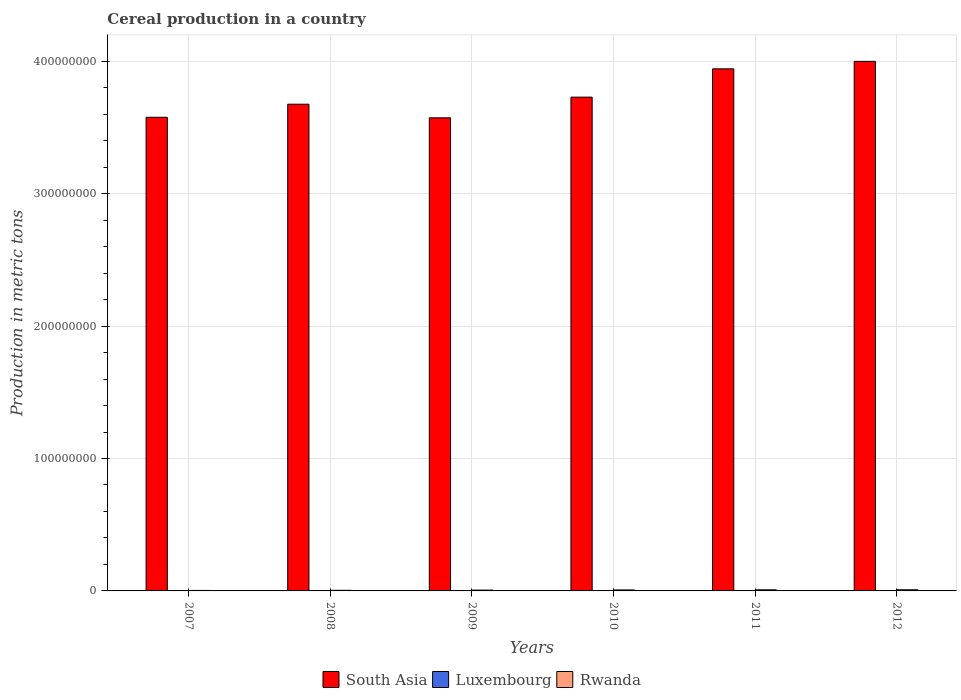How many groups of bars are there?
Provide a short and direct response. 6. How many bars are there on the 6th tick from the left?
Provide a succinct answer. 3. What is the label of the 5th group of bars from the left?
Provide a short and direct response. 2011. What is the total cereal production in Rwanda in 2009?
Offer a very short reply. 6.22e+05. Across all years, what is the maximum total cereal production in Rwanda?
Provide a succinct answer. 8.81e+05. Across all years, what is the minimum total cereal production in Luxembourg?
Offer a very short reply. 1.48e+05. In which year was the total cereal production in Luxembourg maximum?
Provide a succinct answer. 2008. In which year was the total cereal production in Luxembourg minimum?
Your response must be concise. 2007. What is the total total cereal production in Rwanda in the graph?
Your answer should be compact. 3.93e+06. What is the difference between the total cereal production in Rwanda in 2007 and that in 2010?
Offer a very short reply. -3.89e+05. What is the difference between the total cereal production in South Asia in 2007 and the total cereal production in Luxembourg in 2012?
Give a very brief answer. 3.57e+08. What is the average total cereal production in Rwanda per year?
Keep it short and to the point. 6.55e+05. In the year 2007, what is the difference between the total cereal production in South Asia and total cereal production in Luxembourg?
Give a very brief answer. 3.57e+08. What is the ratio of the total cereal production in South Asia in 2010 to that in 2011?
Ensure brevity in your answer.  0.95. Is the total cereal production in Rwanda in 2008 less than that in 2009?
Your response must be concise. Yes. What is the difference between the highest and the second highest total cereal production in Rwanda?
Your answer should be compact. 2.34e+04. What is the difference between the highest and the lowest total cereal production in Luxembourg?
Your answer should be compact. 4.24e+04. Is the sum of the total cereal production in South Asia in 2010 and 2011 greater than the maximum total cereal production in Luxembourg across all years?
Your answer should be compact. Yes. What does the 3rd bar from the left in 2007 represents?
Offer a terse response. Rwanda. What does the 1st bar from the right in 2009 represents?
Make the answer very short. Rwanda. How many bars are there?
Offer a very short reply. 18. How many years are there in the graph?
Keep it short and to the point. 6. What is the difference between two consecutive major ticks on the Y-axis?
Keep it short and to the point. 1.00e+08. Does the graph contain grids?
Your answer should be compact. Yes. How many legend labels are there?
Provide a short and direct response. 3. What is the title of the graph?
Your answer should be compact. Cereal production in a country. What is the label or title of the Y-axis?
Provide a short and direct response. Production in metric tons. What is the Production in metric tons of South Asia in 2007?
Provide a short and direct response. 3.58e+08. What is the Production in metric tons of Luxembourg in 2007?
Keep it short and to the point. 1.48e+05. What is the Production in metric tons of Rwanda in 2007?
Your response must be concise. 3.56e+05. What is the Production in metric tons of South Asia in 2008?
Make the answer very short. 3.68e+08. What is the Production in metric tons of Luxembourg in 2008?
Provide a short and direct response. 1.91e+05. What is the Production in metric tons of Rwanda in 2008?
Offer a very short reply. 4.66e+05. What is the Production in metric tons in South Asia in 2009?
Make the answer very short. 3.57e+08. What is the Production in metric tons of Luxembourg in 2009?
Make the answer very short. 1.89e+05. What is the Production in metric tons in Rwanda in 2009?
Offer a very short reply. 6.22e+05. What is the Production in metric tons of South Asia in 2010?
Your answer should be compact. 3.73e+08. What is the Production in metric tons of Luxembourg in 2010?
Provide a short and direct response. 1.66e+05. What is the Production in metric tons of Rwanda in 2010?
Offer a terse response. 7.46e+05. What is the Production in metric tons in South Asia in 2011?
Your response must be concise. 3.94e+08. What is the Production in metric tons of Luxembourg in 2011?
Keep it short and to the point. 1.50e+05. What is the Production in metric tons of Rwanda in 2011?
Your response must be concise. 8.57e+05. What is the Production in metric tons in South Asia in 2012?
Give a very brief answer. 4.00e+08. What is the Production in metric tons of Luxembourg in 2012?
Offer a terse response. 1.53e+05. What is the Production in metric tons in Rwanda in 2012?
Give a very brief answer. 8.81e+05. Across all years, what is the maximum Production in metric tons in South Asia?
Your answer should be compact. 4.00e+08. Across all years, what is the maximum Production in metric tons in Luxembourg?
Provide a succinct answer. 1.91e+05. Across all years, what is the maximum Production in metric tons of Rwanda?
Ensure brevity in your answer.  8.81e+05. Across all years, what is the minimum Production in metric tons of South Asia?
Provide a short and direct response. 3.57e+08. Across all years, what is the minimum Production in metric tons in Luxembourg?
Offer a very short reply. 1.48e+05. Across all years, what is the minimum Production in metric tons of Rwanda?
Offer a terse response. 3.56e+05. What is the total Production in metric tons of South Asia in the graph?
Offer a very short reply. 2.25e+09. What is the total Production in metric tons in Luxembourg in the graph?
Provide a succinct answer. 9.97e+05. What is the total Production in metric tons of Rwanda in the graph?
Your answer should be compact. 3.93e+06. What is the difference between the Production in metric tons of South Asia in 2007 and that in 2008?
Ensure brevity in your answer.  -9.87e+06. What is the difference between the Production in metric tons of Luxembourg in 2007 and that in 2008?
Your answer should be very brief. -4.24e+04. What is the difference between the Production in metric tons in Rwanda in 2007 and that in 2008?
Your answer should be compact. -1.10e+05. What is the difference between the Production in metric tons of South Asia in 2007 and that in 2009?
Ensure brevity in your answer.  4.02e+05. What is the difference between the Production in metric tons in Luxembourg in 2007 and that in 2009?
Make the answer very short. -4.02e+04. What is the difference between the Production in metric tons of Rwanda in 2007 and that in 2009?
Provide a short and direct response. -2.66e+05. What is the difference between the Production in metric tons of South Asia in 2007 and that in 2010?
Make the answer very short. -1.52e+07. What is the difference between the Production in metric tons in Luxembourg in 2007 and that in 2010?
Offer a very short reply. -1.78e+04. What is the difference between the Production in metric tons in Rwanda in 2007 and that in 2010?
Provide a short and direct response. -3.89e+05. What is the difference between the Production in metric tons of South Asia in 2007 and that in 2011?
Make the answer very short. -3.66e+07. What is the difference between the Production in metric tons of Luxembourg in 2007 and that in 2011?
Provide a succinct answer. -1240. What is the difference between the Production in metric tons in Rwanda in 2007 and that in 2011?
Make the answer very short. -5.01e+05. What is the difference between the Production in metric tons in South Asia in 2007 and that in 2012?
Offer a terse response. -4.22e+07. What is the difference between the Production in metric tons of Luxembourg in 2007 and that in 2012?
Offer a very short reply. -5082. What is the difference between the Production in metric tons in Rwanda in 2007 and that in 2012?
Provide a succinct answer. -5.25e+05. What is the difference between the Production in metric tons of South Asia in 2008 and that in 2009?
Your answer should be very brief. 1.03e+07. What is the difference between the Production in metric tons of Luxembourg in 2008 and that in 2009?
Provide a succinct answer. 2160. What is the difference between the Production in metric tons in Rwanda in 2008 and that in 2009?
Your answer should be compact. -1.56e+05. What is the difference between the Production in metric tons in South Asia in 2008 and that in 2010?
Your answer should be compact. -5.33e+06. What is the difference between the Production in metric tons in Luxembourg in 2008 and that in 2010?
Provide a short and direct response. 2.45e+04. What is the difference between the Production in metric tons of Rwanda in 2008 and that in 2010?
Ensure brevity in your answer.  -2.80e+05. What is the difference between the Production in metric tons of South Asia in 2008 and that in 2011?
Give a very brief answer. -2.67e+07. What is the difference between the Production in metric tons in Luxembourg in 2008 and that in 2011?
Make the answer very short. 4.11e+04. What is the difference between the Production in metric tons of Rwanda in 2008 and that in 2011?
Make the answer very short. -3.91e+05. What is the difference between the Production in metric tons in South Asia in 2008 and that in 2012?
Offer a terse response. -3.24e+07. What is the difference between the Production in metric tons of Luxembourg in 2008 and that in 2012?
Ensure brevity in your answer.  3.73e+04. What is the difference between the Production in metric tons of Rwanda in 2008 and that in 2012?
Make the answer very short. -4.15e+05. What is the difference between the Production in metric tons of South Asia in 2009 and that in 2010?
Your answer should be very brief. -1.56e+07. What is the difference between the Production in metric tons in Luxembourg in 2009 and that in 2010?
Give a very brief answer. 2.24e+04. What is the difference between the Production in metric tons of Rwanda in 2009 and that in 2010?
Your answer should be compact. -1.24e+05. What is the difference between the Production in metric tons in South Asia in 2009 and that in 2011?
Offer a terse response. -3.70e+07. What is the difference between the Production in metric tons of Luxembourg in 2009 and that in 2011?
Provide a short and direct response. 3.90e+04. What is the difference between the Production in metric tons of Rwanda in 2009 and that in 2011?
Ensure brevity in your answer.  -2.35e+05. What is the difference between the Production in metric tons of South Asia in 2009 and that in 2012?
Make the answer very short. -4.26e+07. What is the difference between the Production in metric tons in Luxembourg in 2009 and that in 2012?
Your answer should be very brief. 3.51e+04. What is the difference between the Production in metric tons of Rwanda in 2009 and that in 2012?
Your response must be concise. -2.59e+05. What is the difference between the Production in metric tons of South Asia in 2010 and that in 2011?
Offer a terse response. -2.14e+07. What is the difference between the Production in metric tons of Luxembourg in 2010 and that in 2011?
Keep it short and to the point. 1.66e+04. What is the difference between the Production in metric tons in Rwanda in 2010 and that in 2011?
Offer a terse response. -1.12e+05. What is the difference between the Production in metric tons of South Asia in 2010 and that in 2012?
Your answer should be compact. -2.70e+07. What is the difference between the Production in metric tons of Luxembourg in 2010 and that in 2012?
Offer a very short reply. 1.28e+04. What is the difference between the Production in metric tons in Rwanda in 2010 and that in 2012?
Your response must be concise. -1.35e+05. What is the difference between the Production in metric tons in South Asia in 2011 and that in 2012?
Give a very brief answer. -5.65e+06. What is the difference between the Production in metric tons in Luxembourg in 2011 and that in 2012?
Provide a short and direct response. -3842. What is the difference between the Production in metric tons of Rwanda in 2011 and that in 2012?
Offer a very short reply. -2.34e+04. What is the difference between the Production in metric tons in South Asia in 2007 and the Production in metric tons in Luxembourg in 2008?
Make the answer very short. 3.57e+08. What is the difference between the Production in metric tons of South Asia in 2007 and the Production in metric tons of Rwanda in 2008?
Provide a succinct answer. 3.57e+08. What is the difference between the Production in metric tons of Luxembourg in 2007 and the Production in metric tons of Rwanda in 2008?
Ensure brevity in your answer.  -3.17e+05. What is the difference between the Production in metric tons of South Asia in 2007 and the Production in metric tons of Luxembourg in 2009?
Ensure brevity in your answer.  3.57e+08. What is the difference between the Production in metric tons in South Asia in 2007 and the Production in metric tons in Rwanda in 2009?
Your answer should be very brief. 3.57e+08. What is the difference between the Production in metric tons in Luxembourg in 2007 and the Production in metric tons in Rwanda in 2009?
Provide a succinct answer. -4.74e+05. What is the difference between the Production in metric tons in South Asia in 2007 and the Production in metric tons in Luxembourg in 2010?
Give a very brief answer. 3.57e+08. What is the difference between the Production in metric tons in South Asia in 2007 and the Production in metric tons in Rwanda in 2010?
Provide a short and direct response. 3.57e+08. What is the difference between the Production in metric tons in Luxembourg in 2007 and the Production in metric tons in Rwanda in 2010?
Ensure brevity in your answer.  -5.97e+05. What is the difference between the Production in metric tons in South Asia in 2007 and the Production in metric tons in Luxembourg in 2011?
Your answer should be compact. 3.57e+08. What is the difference between the Production in metric tons of South Asia in 2007 and the Production in metric tons of Rwanda in 2011?
Offer a terse response. 3.57e+08. What is the difference between the Production in metric tons of Luxembourg in 2007 and the Production in metric tons of Rwanda in 2011?
Offer a very short reply. -7.09e+05. What is the difference between the Production in metric tons of South Asia in 2007 and the Production in metric tons of Luxembourg in 2012?
Provide a short and direct response. 3.57e+08. What is the difference between the Production in metric tons of South Asia in 2007 and the Production in metric tons of Rwanda in 2012?
Ensure brevity in your answer.  3.57e+08. What is the difference between the Production in metric tons of Luxembourg in 2007 and the Production in metric tons of Rwanda in 2012?
Ensure brevity in your answer.  -7.32e+05. What is the difference between the Production in metric tons in South Asia in 2008 and the Production in metric tons in Luxembourg in 2009?
Offer a very short reply. 3.67e+08. What is the difference between the Production in metric tons in South Asia in 2008 and the Production in metric tons in Rwanda in 2009?
Give a very brief answer. 3.67e+08. What is the difference between the Production in metric tons in Luxembourg in 2008 and the Production in metric tons in Rwanda in 2009?
Offer a very short reply. -4.31e+05. What is the difference between the Production in metric tons in South Asia in 2008 and the Production in metric tons in Luxembourg in 2010?
Offer a terse response. 3.67e+08. What is the difference between the Production in metric tons of South Asia in 2008 and the Production in metric tons of Rwanda in 2010?
Make the answer very short. 3.67e+08. What is the difference between the Production in metric tons in Luxembourg in 2008 and the Production in metric tons in Rwanda in 2010?
Your answer should be very brief. -5.55e+05. What is the difference between the Production in metric tons in South Asia in 2008 and the Production in metric tons in Luxembourg in 2011?
Offer a very short reply. 3.67e+08. What is the difference between the Production in metric tons of South Asia in 2008 and the Production in metric tons of Rwanda in 2011?
Make the answer very short. 3.67e+08. What is the difference between the Production in metric tons in Luxembourg in 2008 and the Production in metric tons in Rwanda in 2011?
Give a very brief answer. -6.67e+05. What is the difference between the Production in metric tons in South Asia in 2008 and the Production in metric tons in Luxembourg in 2012?
Your answer should be very brief. 3.67e+08. What is the difference between the Production in metric tons of South Asia in 2008 and the Production in metric tons of Rwanda in 2012?
Provide a succinct answer. 3.67e+08. What is the difference between the Production in metric tons of Luxembourg in 2008 and the Production in metric tons of Rwanda in 2012?
Provide a short and direct response. -6.90e+05. What is the difference between the Production in metric tons in South Asia in 2009 and the Production in metric tons in Luxembourg in 2010?
Make the answer very short. 3.57e+08. What is the difference between the Production in metric tons of South Asia in 2009 and the Production in metric tons of Rwanda in 2010?
Your answer should be compact. 3.56e+08. What is the difference between the Production in metric tons of Luxembourg in 2009 and the Production in metric tons of Rwanda in 2010?
Offer a very short reply. -5.57e+05. What is the difference between the Production in metric tons in South Asia in 2009 and the Production in metric tons in Luxembourg in 2011?
Keep it short and to the point. 3.57e+08. What is the difference between the Production in metric tons of South Asia in 2009 and the Production in metric tons of Rwanda in 2011?
Make the answer very short. 3.56e+08. What is the difference between the Production in metric tons of Luxembourg in 2009 and the Production in metric tons of Rwanda in 2011?
Ensure brevity in your answer.  -6.69e+05. What is the difference between the Production in metric tons in South Asia in 2009 and the Production in metric tons in Luxembourg in 2012?
Your answer should be very brief. 3.57e+08. What is the difference between the Production in metric tons of South Asia in 2009 and the Production in metric tons of Rwanda in 2012?
Ensure brevity in your answer.  3.56e+08. What is the difference between the Production in metric tons in Luxembourg in 2009 and the Production in metric tons in Rwanda in 2012?
Keep it short and to the point. -6.92e+05. What is the difference between the Production in metric tons of South Asia in 2010 and the Production in metric tons of Luxembourg in 2011?
Provide a succinct answer. 3.73e+08. What is the difference between the Production in metric tons of South Asia in 2010 and the Production in metric tons of Rwanda in 2011?
Your answer should be compact. 3.72e+08. What is the difference between the Production in metric tons of Luxembourg in 2010 and the Production in metric tons of Rwanda in 2011?
Provide a short and direct response. -6.91e+05. What is the difference between the Production in metric tons of South Asia in 2010 and the Production in metric tons of Luxembourg in 2012?
Make the answer very short. 3.73e+08. What is the difference between the Production in metric tons in South Asia in 2010 and the Production in metric tons in Rwanda in 2012?
Offer a very short reply. 3.72e+08. What is the difference between the Production in metric tons of Luxembourg in 2010 and the Production in metric tons of Rwanda in 2012?
Give a very brief answer. -7.15e+05. What is the difference between the Production in metric tons in South Asia in 2011 and the Production in metric tons in Luxembourg in 2012?
Offer a very short reply. 3.94e+08. What is the difference between the Production in metric tons of South Asia in 2011 and the Production in metric tons of Rwanda in 2012?
Make the answer very short. 3.93e+08. What is the difference between the Production in metric tons of Luxembourg in 2011 and the Production in metric tons of Rwanda in 2012?
Provide a succinct answer. -7.31e+05. What is the average Production in metric tons of South Asia per year?
Make the answer very short. 3.75e+08. What is the average Production in metric tons of Luxembourg per year?
Your answer should be compact. 1.66e+05. What is the average Production in metric tons of Rwanda per year?
Keep it short and to the point. 6.55e+05. In the year 2007, what is the difference between the Production in metric tons of South Asia and Production in metric tons of Luxembourg?
Offer a terse response. 3.57e+08. In the year 2007, what is the difference between the Production in metric tons in South Asia and Production in metric tons in Rwanda?
Provide a succinct answer. 3.57e+08. In the year 2007, what is the difference between the Production in metric tons in Luxembourg and Production in metric tons in Rwanda?
Make the answer very short. -2.08e+05. In the year 2008, what is the difference between the Production in metric tons of South Asia and Production in metric tons of Luxembourg?
Keep it short and to the point. 3.67e+08. In the year 2008, what is the difference between the Production in metric tons of South Asia and Production in metric tons of Rwanda?
Keep it short and to the point. 3.67e+08. In the year 2008, what is the difference between the Production in metric tons of Luxembourg and Production in metric tons of Rwanda?
Offer a very short reply. -2.75e+05. In the year 2009, what is the difference between the Production in metric tons of South Asia and Production in metric tons of Luxembourg?
Ensure brevity in your answer.  3.57e+08. In the year 2009, what is the difference between the Production in metric tons of South Asia and Production in metric tons of Rwanda?
Provide a succinct answer. 3.57e+08. In the year 2009, what is the difference between the Production in metric tons in Luxembourg and Production in metric tons in Rwanda?
Provide a succinct answer. -4.33e+05. In the year 2010, what is the difference between the Production in metric tons of South Asia and Production in metric tons of Luxembourg?
Your answer should be compact. 3.73e+08. In the year 2010, what is the difference between the Production in metric tons in South Asia and Production in metric tons in Rwanda?
Provide a succinct answer. 3.72e+08. In the year 2010, what is the difference between the Production in metric tons in Luxembourg and Production in metric tons in Rwanda?
Ensure brevity in your answer.  -5.79e+05. In the year 2011, what is the difference between the Production in metric tons in South Asia and Production in metric tons in Luxembourg?
Provide a short and direct response. 3.94e+08. In the year 2011, what is the difference between the Production in metric tons in South Asia and Production in metric tons in Rwanda?
Give a very brief answer. 3.93e+08. In the year 2011, what is the difference between the Production in metric tons of Luxembourg and Production in metric tons of Rwanda?
Offer a very short reply. -7.08e+05. In the year 2012, what is the difference between the Production in metric tons of South Asia and Production in metric tons of Luxembourg?
Your answer should be compact. 4.00e+08. In the year 2012, what is the difference between the Production in metric tons of South Asia and Production in metric tons of Rwanda?
Give a very brief answer. 3.99e+08. In the year 2012, what is the difference between the Production in metric tons of Luxembourg and Production in metric tons of Rwanda?
Provide a succinct answer. -7.27e+05. What is the ratio of the Production in metric tons of South Asia in 2007 to that in 2008?
Your answer should be very brief. 0.97. What is the ratio of the Production in metric tons in Rwanda in 2007 to that in 2008?
Your answer should be compact. 0.76. What is the ratio of the Production in metric tons of Luxembourg in 2007 to that in 2009?
Keep it short and to the point. 0.79. What is the ratio of the Production in metric tons in Rwanda in 2007 to that in 2009?
Provide a succinct answer. 0.57. What is the ratio of the Production in metric tons in South Asia in 2007 to that in 2010?
Offer a very short reply. 0.96. What is the ratio of the Production in metric tons in Luxembourg in 2007 to that in 2010?
Offer a very short reply. 0.89. What is the ratio of the Production in metric tons of Rwanda in 2007 to that in 2010?
Keep it short and to the point. 0.48. What is the ratio of the Production in metric tons of South Asia in 2007 to that in 2011?
Your answer should be compact. 0.91. What is the ratio of the Production in metric tons in Luxembourg in 2007 to that in 2011?
Provide a succinct answer. 0.99. What is the ratio of the Production in metric tons of Rwanda in 2007 to that in 2011?
Provide a short and direct response. 0.42. What is the ratio of the Production in metric tons in South Asia in 2007 to that in 2012?
Offer a terse response. 0.89. What is the ratio of the Production in metric tons of Luxembourg in 2007 to that in 2012?
Offer a terse response. 0.97. What is the ratio of the Production in metric tons in Rwanda in 2007 to that in 2012?
Your response must be concise. 0.4. What is the ratio of the Production in metric tons of South Asia in 2008 to that in 2009?
Your response must be concise. 1.03. What is the ratio of the Production in metric tons in Luxembourg in 2008 to that in 2009?
Your response must be concise. 1.01. What is the ratio of the Production in metric tons in Rwanda in 2008 to that in 2009?
Offer a very short reply. 0.75. What is the ratio of the Production in metric tons in South Asia in 2008 to that in 2010?
Your answer should be compact. 0.99. What is the ratio of the Production in metric tons in Luxembourg in 2008 to that in 2010?
Offer a terse response. 1.15. What is the ratio of the Production in metric tons in Rwanda in 2008 to that in 2010?
Provide a succinct answer. 0.62. What is the ratio of the Production in metric tons in South Asia in 2008 to that in 2011?
Offer a very short reply. 0.93. What is the ratio of the Production in metric tons in Luxembourg in 2008 to that in 2011?
Make the answer very short. 1.27. What is the ratio of the Production in metric tons of Rwanda in 2008 to that in 2011?
Give a very brief answer. 0.54. What is the ratio of the Production in metric tons in South Asia in 2008 to that in 2012?
Offer a terse response. 0.92. What is the ratio of the Production in metric tons in Luxembourg in 2008 to that in 2012?
Provide a succinct answer. 1.24. What is the ratio of the Production in metric tons in Rwanda in 2008 to that in 2012?
Your answer should be very brief. 0.53. What is the ratio of the Production in metric tons in South Asia in 2009 to that in 2010?
Your answer should be very brief. 0.96. What is the ratio of the Production in metric tons of Luxembourg in 2009 to that in 2010?
Keep it short and to the point. 1.13. What is the ratio of the Production in metric tons of Rwanda in 2009 to that in 2010?
Offer a very short reply. 0.83. What is the ratio of the Production in metric tons in South Asia in 2009 to that in 2011?
Your response must be concise. 0.91. What is the ratio of the Production in metric tons of Luxembourg in 2009 to that in 2011?
Your answer should be very brief. 1.26. What is the ratio of the Production in metric tons of Rwanda in 2009 to that in 2011?
Give a very brief answer. 0.73. What is the ratio of the Production in metric tons of South Asia in 2009 to that in 2012?
Make the answer very short. 0.89. What is the ratio of the Production in metric tons of Luxembourg in 2009 to that in 2012?
Ensure brevity in your answer.  1.23. What is the ratio of the Production in metric tons in Rwanda in 2009 to that in 2012?
Your answer should be compact. 0.71. What is the ratio of the Production in metric tons in South Asia in 2010 to that in 2011?
Offer a terse response. 0.95. What is the ratio of the Production in metric tons of Luxembourg in 2010 to that in 2011?
Your answer should be very brief. 1.11. What is the ratio of the Production in metric tons in Rwanda in 2010 to that in 2011?
Make the answer very short. 0.87. What is the ratio of the Production in metric tons in South Asia in 2010 to that in 2012?
Ensure brevity in your answer.  0.93. What is the ratio of the Production in metric tons of Luxembourg in 2010 to that in 2012?
Provide a succinct answer. 1.08. What is the ratio of the Production in metric tons of Rwanda in 2010 to that in 2012?
Your response must be concise. 0.85. What is the ratio of the Production in metric tons in South Asia in 2011 to that in 2012?
Provide a succinct answer. 0.99. What is the ratio of the Production in metric tons in Rwanda in 2011 to that in 2012?
Make the answer very short. 0.97. What is the difference between the highest and the second highest Production in metric tons of South Asia?
Make the answer very short. 5.65e+06. What is the difference between the highest and the second highest Production in metric tons of Luxembourg?
Your answer should be compact. 2160. What is the difference between the highest and the second highest Production in metric tons in Rwanda?
Provide a short and direct response. 2.34e+04. What is the difference between the highest and the lowest Production in metric tons in South Asia?
Keep it short and to the point. 4.26e+07. What is the difference between the highest and the lowest Production in metric tons of Luxembourg?
Your response must be concise. 4.24e+04. What is the difference between the highest and the lowest Production in metric tons in Rwanda?
Keep it short and to the point. 5.25e+05. 